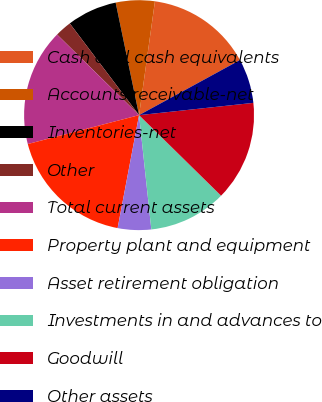Convert chart. <chart><loc_0><loc_0><loc_500><loc_500><pie_chart><fcel>Cash and cash equivalents<fcel>Accounts receivable-net<fcel>Inventories-net<fcel>Other<fcel>Total current assets<fcel>Property plant and equipment<fcel>Asset retirement obligation<fcel>Investments in and advances to<fcel>Goodwill<fcel>Other assets<nl><fcel>14.84%<fcel>5.47%<fcel>7.03%<fcel>2.34%<fcel>16.41%<fcel>17.97%<fcel>4.69%<fcel>10.94%<fcel>14.06%<fcel>6.25%<nl></chart> 